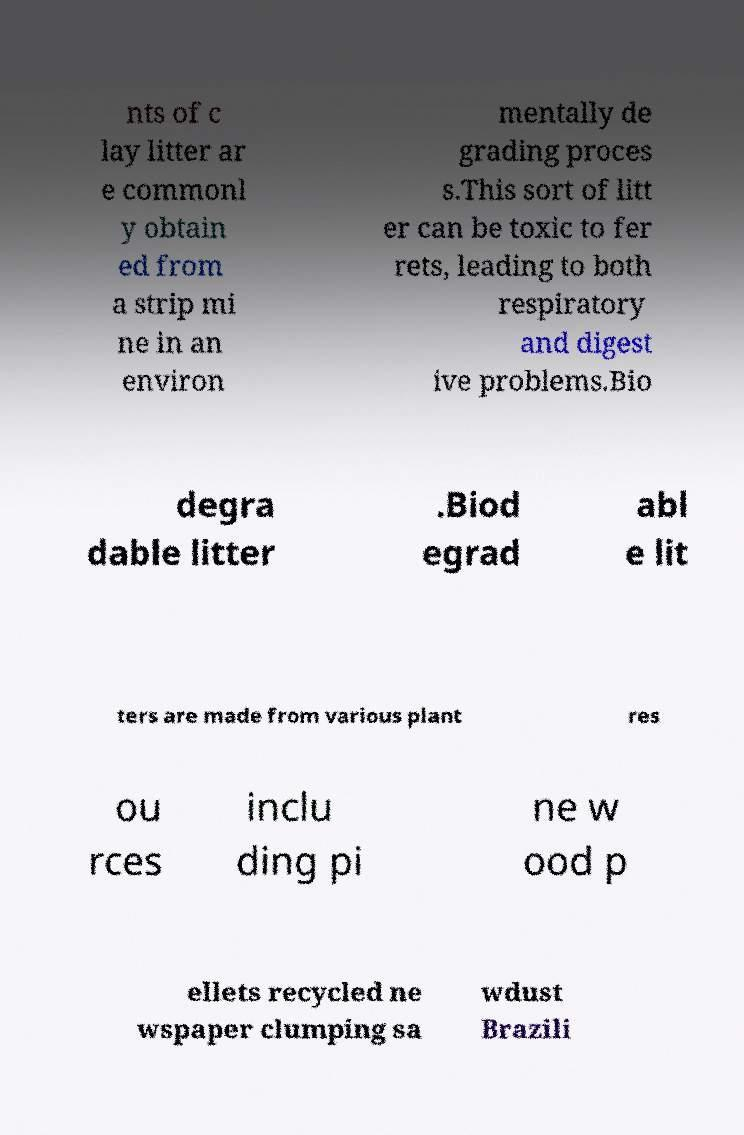Please identify and transcribe the text found in this image. nts of c lay litter ar e commonl y obtain ed from a strip mi ne in an environ mentally de grading proces s.This sort of litt er can be toxic to fer rets, leading to both respiratory and digest ive problems.Bio degra dable litter .Biod egrad abl e lit ters are made from various plant res ou rces inclu ding pi ne w ood p ellets recycled ne wspaper clumping sa wdust Brazili 